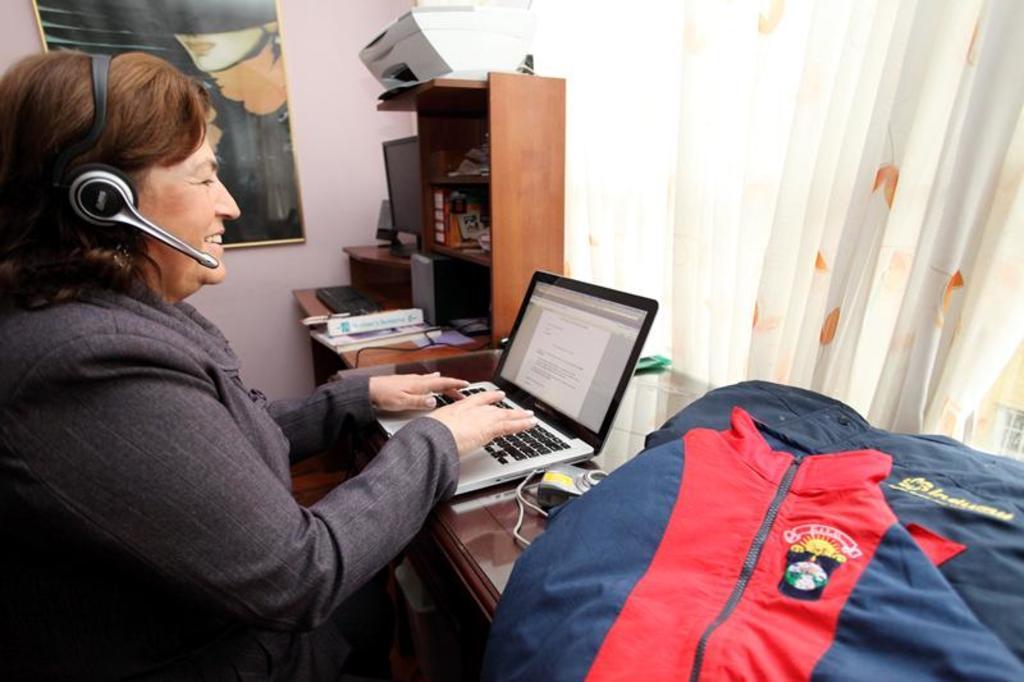Could you give a brief overview of what you see in this image? In the left side a woman is sitting and working in the laptop, she wore a coat, headset. in the right side it is a curtain. 